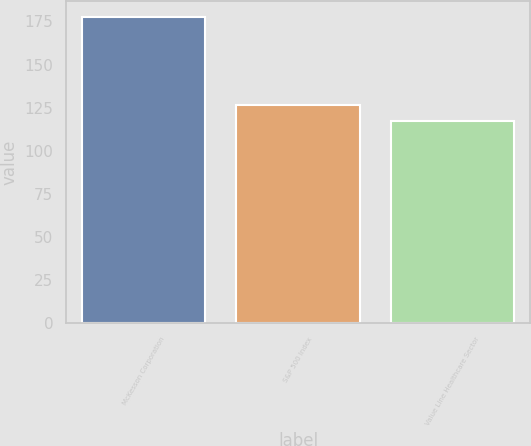<chart> <loc_0><loc_0><loc_500><loc_500><bar_chart><fcel>McKesson Corporation<fcel>S&P 500 Index<fcel>Value Line Healthcare Sector<nl><fcel>177.74<fcel>126.54<fcel>117.35<nl></chart> 